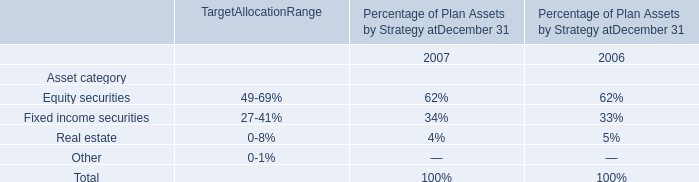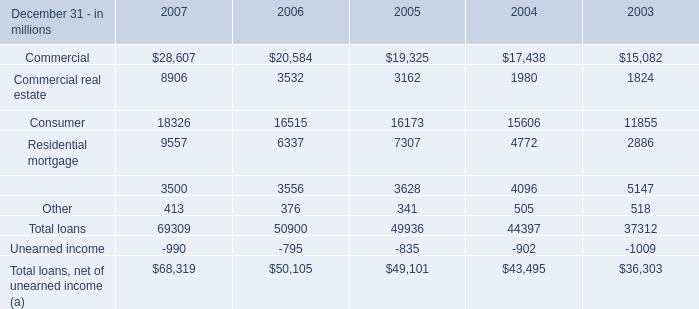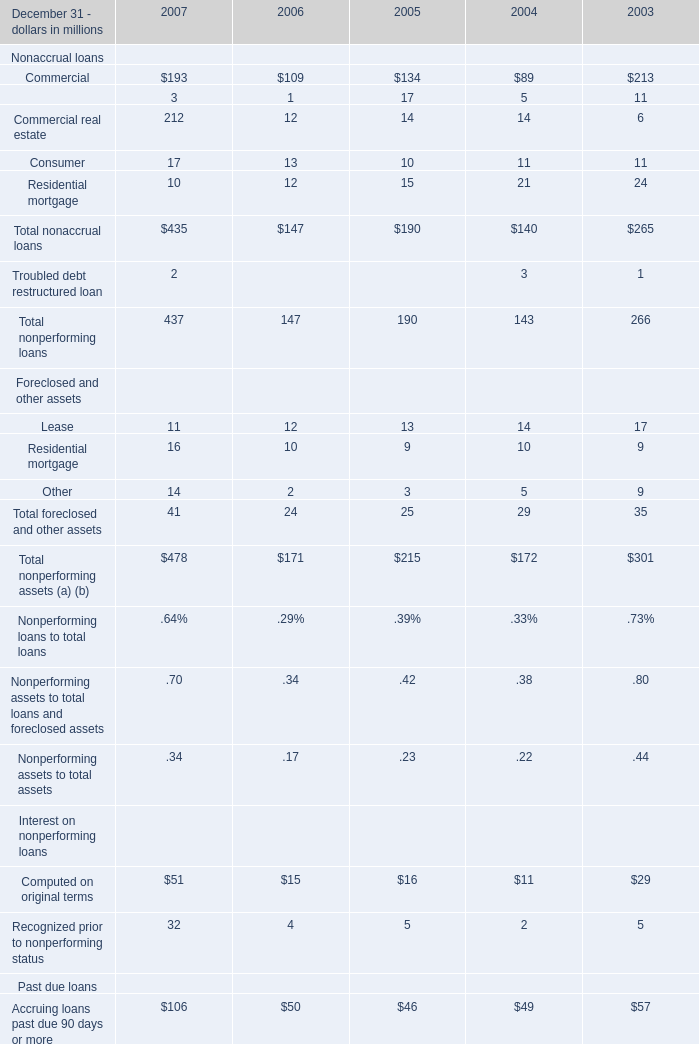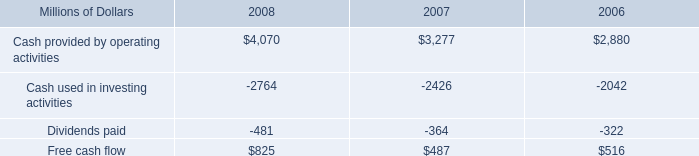Does the value of Lease financing in 2007 greater than that in 2006? 
Answer: NO. 